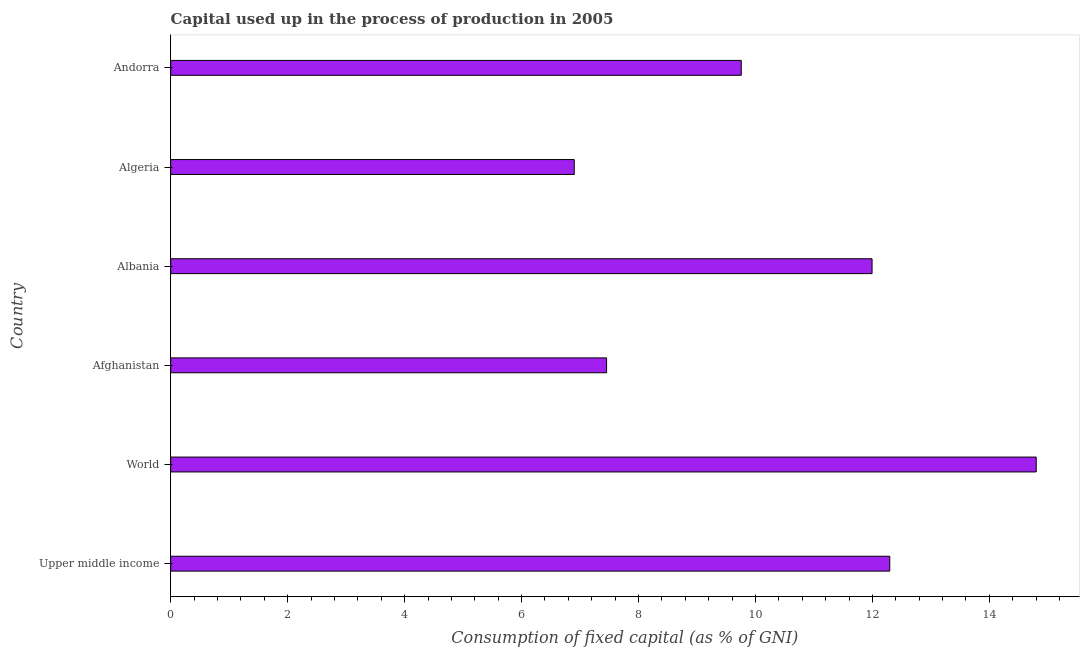What is the title of the graph?
Your answer should be compact. Capital used up in the process of production in 2005. What is the label or title of the X-axis?
Your response must be concise. Consumption of fixed capital (as % of GNI). What is the label or title of the Y-axis?
Provide a succinct answer. Country. What is the consumption of fixed capital in Albania?
Your response must be concise. 11.99. Across all countries, what is the maximum consumption of fixed capital?
Your answer should be very brief. 14.8. Across all countries, what is the minimum consumption of fixed capital?
Offer a very short reply. 6.9. In which country was the consumption of fixed capital minimum?
Give a very brief answer. Algeria. What is the sum of the consumption of fixed capital?
Your answer should be compact. 63.2. What is the difference between the consumption of fixed capital in Albania and Upper middle income?
Your response must be concise. -0.3. What is the average consumption of fixed capital per country?
Offer a very short reply. 10.53. What is the median consumption of fixed capital?
Your answer should be compact. 10.88. In how many countries, is the consumption of fixed capital greater than 8.4 %?
Your response must be concise. 4. Is the consumption of fixed capital in Afghanistan less than that in Algeria?
Make the answer very short. No. What is the difference between the highest and the second highest consumption of fixed capital?
Your answer should be very brief. 2.5. What is the difference between the highest and the lowest consumption of fixed capital?
Offer a terse response. 7.9. Are all the bars in the graph horizontal?
Keep it short and to the point. Yes. How many countries are there in the graph?
Offer a terse response. 6. Are the values on the major ticks of X-axis written in scientific E-notation?
Offer a terse response. No. What is the Consumption of fixed capital (as % of GNI) of Upper middle income?
Give a very brief answer. 12.3. What is the Consumption of fixed capital (as % of GNI) in World?
Your response must be concise. 14.8. What is the Consumption of fixed capital (as % of GNI) in Afghanistan?
Offer a very short reply. 7.45. What is the Consumption of fixed capital (as % of GNI) in Albania?
Offer a terse response. 11.99. What is the Consumption of fixed capital (as % of GNI) of Algeria?
Give a very brief answer. 6.9. What is the Consumption of fixed capital (as % of GNI) of Andorra?
Give a very brief answer. 9.76. What is the difference between the Consumption of fixed capital (as % of GNI) in Upper middle income and World?
Offer a terse response. -2.5. What is the difference between the Consumption of fixed capital (as % of GNI) in Upper middle income and Afghanistan?
Your response must be concise. 4.84. What is the difference between the Consumption of fixed capital (as % of GNI) in Upper middle income and Albania?
Provide a short and direct response. 0.3. What is the difference between the Consumption of fixed capital (as % of GNI) in Upper middle income and Algeria?
Give a very brief answer. 5.4. What is the difference between the Consumption of fixed capital (as % of GNI) in Upper middle income and Andorra?
Ensure brevity in your answer.  2.54. What is the difference between the Consumption of fixed capital (as % of GNI) in World and Afghanistan?
Provide a short and direct response. 7.35. What is the difference between the Consumption of fixed capital (as % of GNI) in World and Albania?
Offer a very short reply. 2.81. What is the difference between the Consumption of fixed capital (as % of GNI) in World and Algeria?
Keep it short and to the point. 7.9. What is the difference between the Consumption of fixed capital (as % of GNI) in World and Andorra?
Offer a terse response. 5.04. What is the difference between the Consumption of fixed capital (as % of GNI) in Afghanistan and Albania?
Provide a short and direct response. -4.54. What is the difference between the Consumption of fixed capital (as % of GNI) in Afghanistan and Algeria?
Make the answer very short. 0.55. What is the difference between the Consumption of fixed capital (as % of GNI) in Afghanistan and Andorra?
Your answer should be compact. -2.3. What is the difference between the Consumption of fixed capital (as % of GNI) in Albania and Algeria?
Your answer should be very brief. 5.09. What is the difference between the Consumption of fixed capital (as % of GNI) in Albania and Andorra?
Provide a short and direct response. 2.24. What is the difference between the Consumption of fixed capital (as % of GNI) in Algeria and Andorra?
Your answer should be very brief. -2.86. What is the ratio of the Consumption of fixed capital (as % of GNI) in Upper middle income to that in World?
Offer a very short reply. 0.83. What is the ratio of the Consumption of fixed capital (as % of GNI) in Upper middle income to that in Afghanistan?
Keep it short and to the point. 1.65. What is the ratio of the Consumption of fixed capital (as % of GNI) in Upper middle income to that in Algeria?
Offer a terse response. 1.78. What is the ratio of the Consumption of fixed capital (as % of GNI) in Upper middle income to that in Andorra?
Offer a terse response. 1.26. What is the ratio of the Consumption of fixed capital (as % of GNI) in World to that in Afghanistan?
Offer a very short reply. 1.99. What is the ratio of the Consumption of fixed capital (as % of GNI) in World to that in Albania?
Your answer should be very brief. 1.23. What is the ratio of the Consumption of fixed capital (as % of GNI) in World to that in Algeria?
Make the answer very short. 2.15. What is the ratio of the Consumption of fixed capital (as % of GNI) in World to that in Andorra?
Make the answer very short. 1.52. What is the ratio of the Consumption of fixed capital (as % of GNI) in Afghanistan to that in Albania?
Give a very brief answer. 0.62. What is the ratio of the Consumption of fixed capital (as % of GNI) in Afghanistan to that in Andorra?
Provide a succinct answer. 0.76. What is the ratio of the Consumption of fixed capital (as % of GNI) in Albania to that in Algeria?
Give a very brief answer. 1.74. What is the ratio of the Consumption of fixed capital (as % of GNI) in Albania to that in Andorra?
Provide a succinct answer. 1.23. What is the ratio of the Consumption of fixed capital (as % of GNI) in Algeria to that in Andorra?
Give a very brief answer. 0.71. 